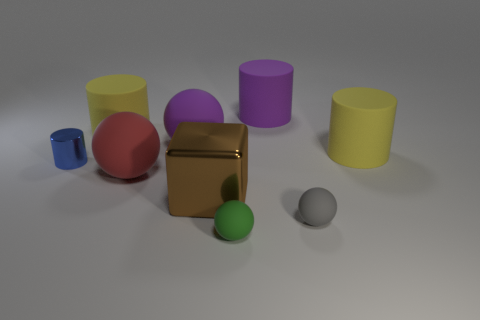How many objects are there in total? There are a total of seven objects in the image — three cylinders, one sphere, one cube, and two smaller spheres. 